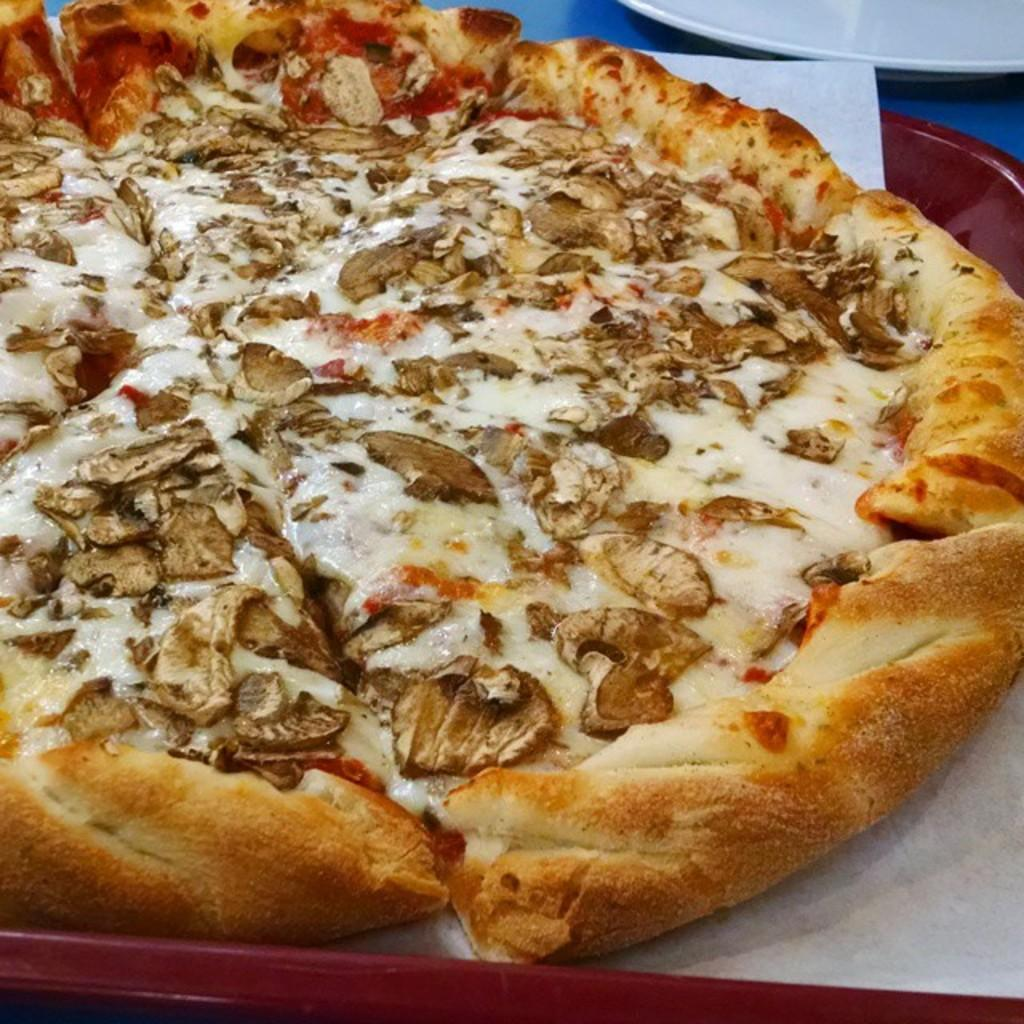What type of food is shown in the image? There is a pizza in the image. Is there anything unusual about the pizza? Yes, there is a paper in the pizza. How is the pizza being served? The pizza is in a plate. Where is the plate with the pizza located? The plate with the pizza is placed on a surface. Can you see any other plates in the image? Yes, there is another plate visible at the top of the image. What type of agreement is being discussed in the image? There is no discussion or agreement present in the image; it features a pizza with a paper in it, a plate, and another plate. How many kittens can be seen playing with the pizza in the image? There are no kittens present in the image; it only shows a pizza with a paper in it, a plate, and another plate. 